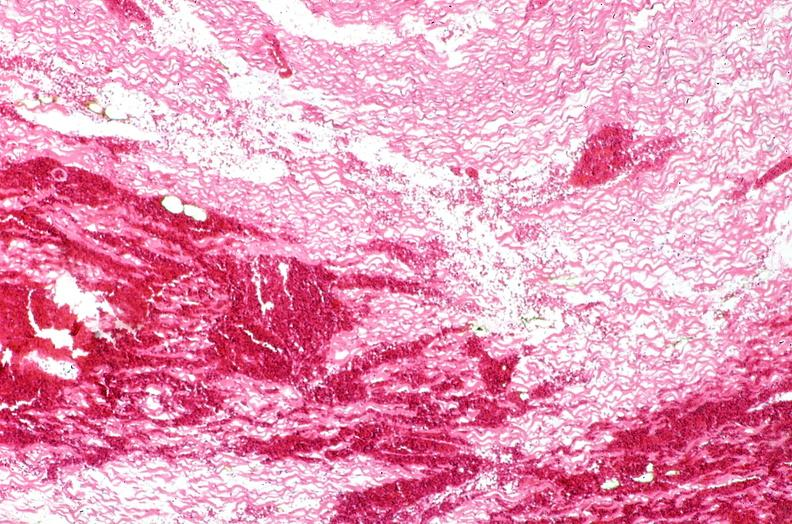what is present?
Answer the question using a single word or phrase. Cardiovascular 